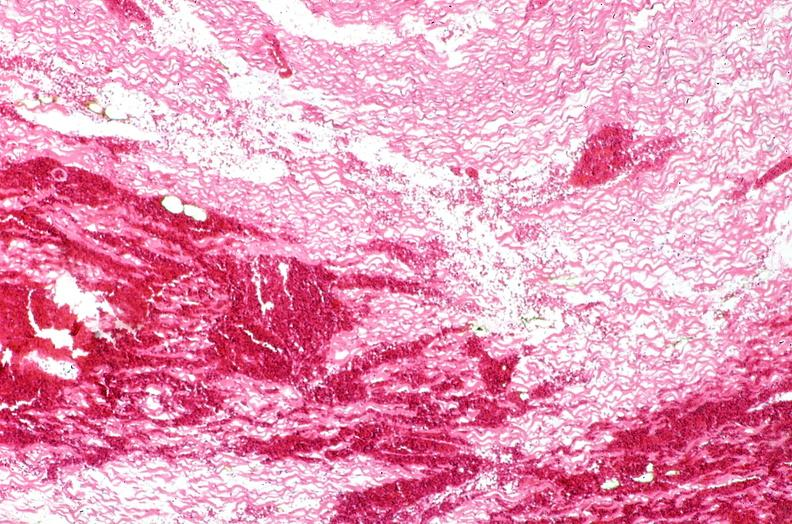what is present?
Answer the question using a single word or phrase. Cardiovascular 